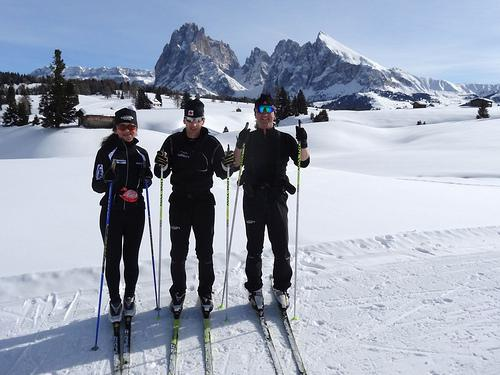Question: how many people are in the photo?
Choices:
A. 4.
B. 7.
C. 3.
D. 9.
Answer with the letter. Answer: C Question: what color are the outfits?
Choices:
A. Green.
B. Black.
C. Blue.
D. Yellow.
Answer with the letter. Answer: B Question: what color are the ski poles?
Choices:
A. Green.
B. Gray.
C. Blue.
D. Yellow.
Answer with the letter. Answer: B Question: why is the ground white?
Choices:
A. From snow.
B. Paint.
C. Frost.
D. Dust.
Answer with the letter. Answer: A Question: when was this photo taken?
Choices:
A. After birth.
B. Before race.
C. Afternoon.
D. During the day.
Answer with the letter. Answer: D Question: where was this photo taken?
Choices:
A. On a ski slope.
B. In the forest.
C. At the beach.
D. In the city.
Answer with the letter. Answer: A Question: who is standing in the snow?
Choices:
A. The people.
B. Kids.
C. Ski patrol.
D. Woman.
Answer with the letter. Answer: A 